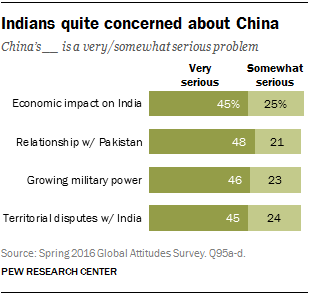List a handful of essential elements in this visual. The value of the first leftmost bar from the bottom is 45. The ratio of the smallest "Very serious" bar and the largest "Somewhat serious" bar is approximately 0.756944444... 